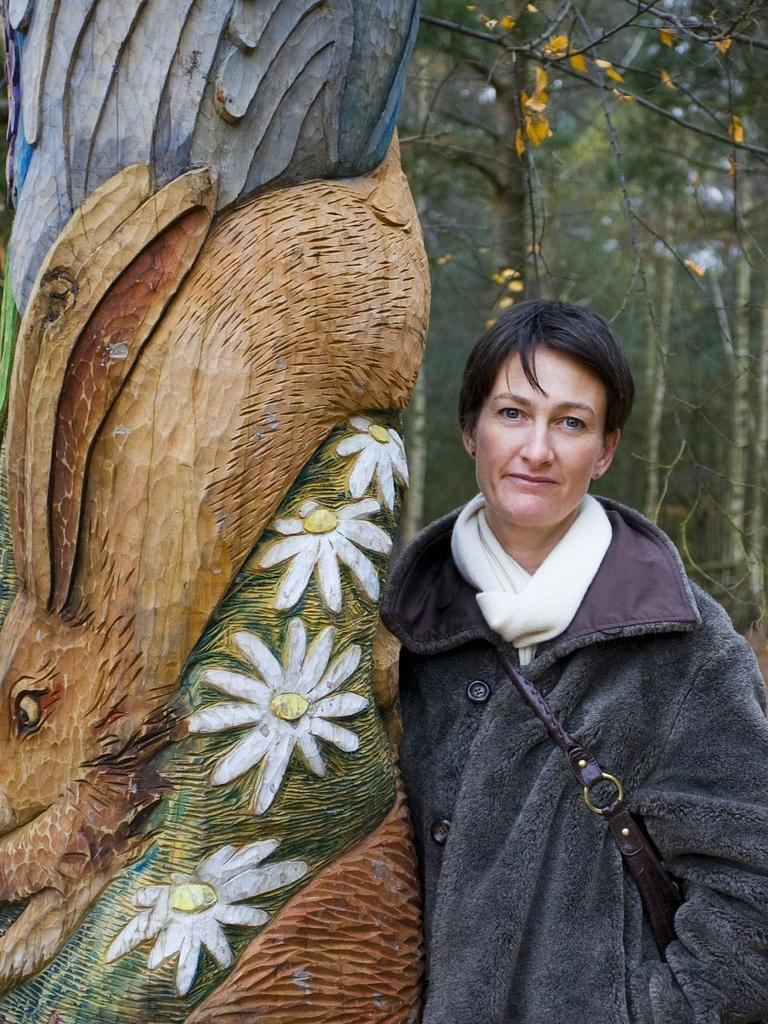Who or what is present in the image? There is a person in the image. What is the person wearing? The person is wearing a jacket and a scarf. What is the person standing beside? The person is standing beside a wooden trunk. What is special about the wooden trunk? The wooden trunk is carved with the shape of flowers. What can be seen on the right side of the image? There are trees on the right side of the image. How much money is the person holding in the image? There is no indication in the image that the person is holding money. 